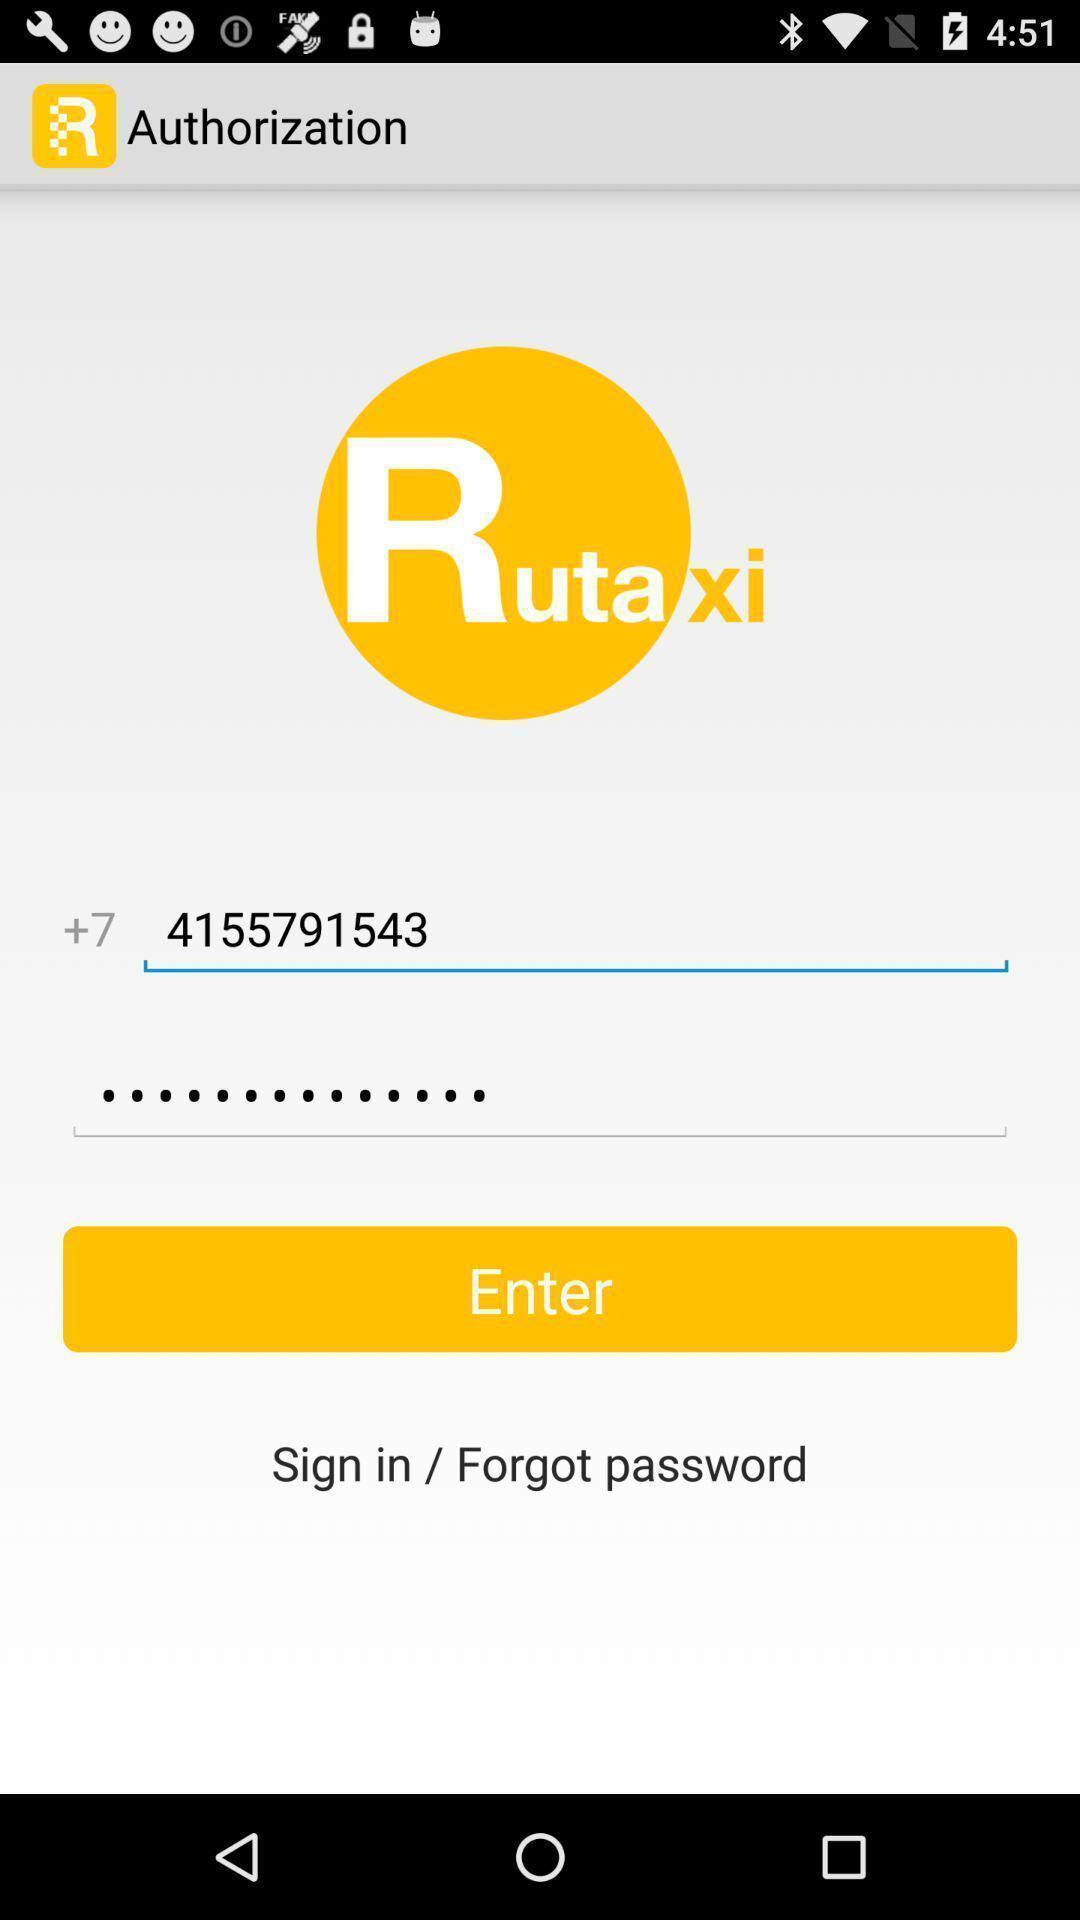Summarize the information in this screenshot. Sign-in page of the vehicle booking app. 